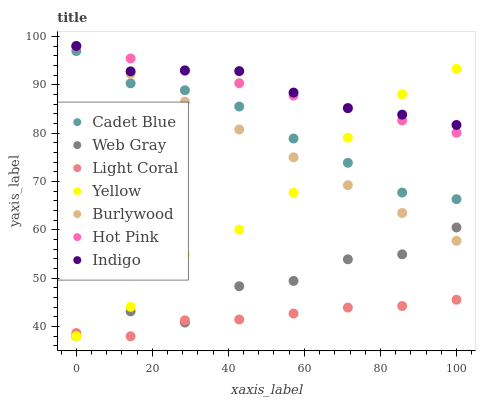Does Light Coral have the minimum area under the curve?
Answer yes or no. Yes. Does Indigo have the maximum area under the curve?
Answer yes or no. Yes. Does Burlywood have the minimum area under the curve?
Answer yes or no. No. Does Burlywood have the maximum area under the curve?
Answer yes or no. No. Is Hot Pink the smoothest?
Answer yes or no. Yes. Is Web Gray the roughest?
Answer yes or no. Yes. Is Indigo the smoothest?
Answer yes or no. No. Is Indigo the roughest?
Answer yes or no. No. Does Yellow have the lowest value?
Answer yes or no. Yes. Does Burlywood have the lowest value?
Answer yes or no. No. Does Hot Pink have the highest value?
Answer yes or no. Yes. Does Yellow have the highest value?
Answer yes or no. No. Is Web Gray less than Indigo?
Answer yes or no. Yes. Is Indigo greater than Light Coral?
Answer yes or no. Yes. Does Web Gray intersect Light Coral?
Answer yes or no. Yes. Is Web Gray less than Light Coral?
Answer yes or no. No. Is Web Gray greater than Light Coral?
Answer yes or no. No. Does Web Gray intersect Indigo?
Answer yes or no. No. 